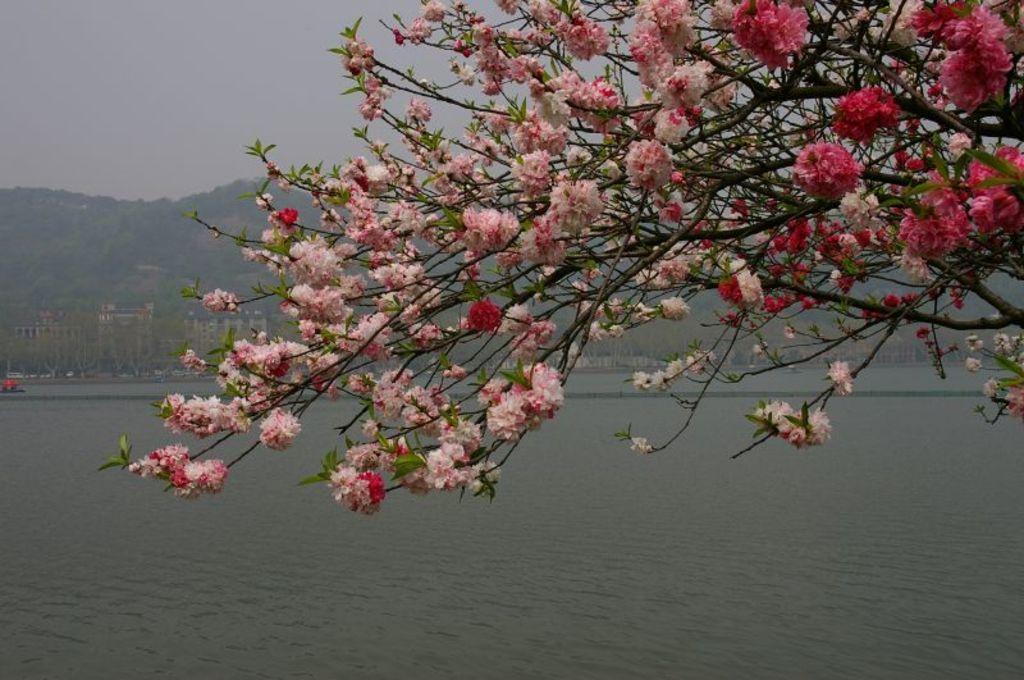Please provide a concise description of this image. In this image in the middle, there are trees, flowers and stems. At the bottom there is water. In the background there are hills and sky. 